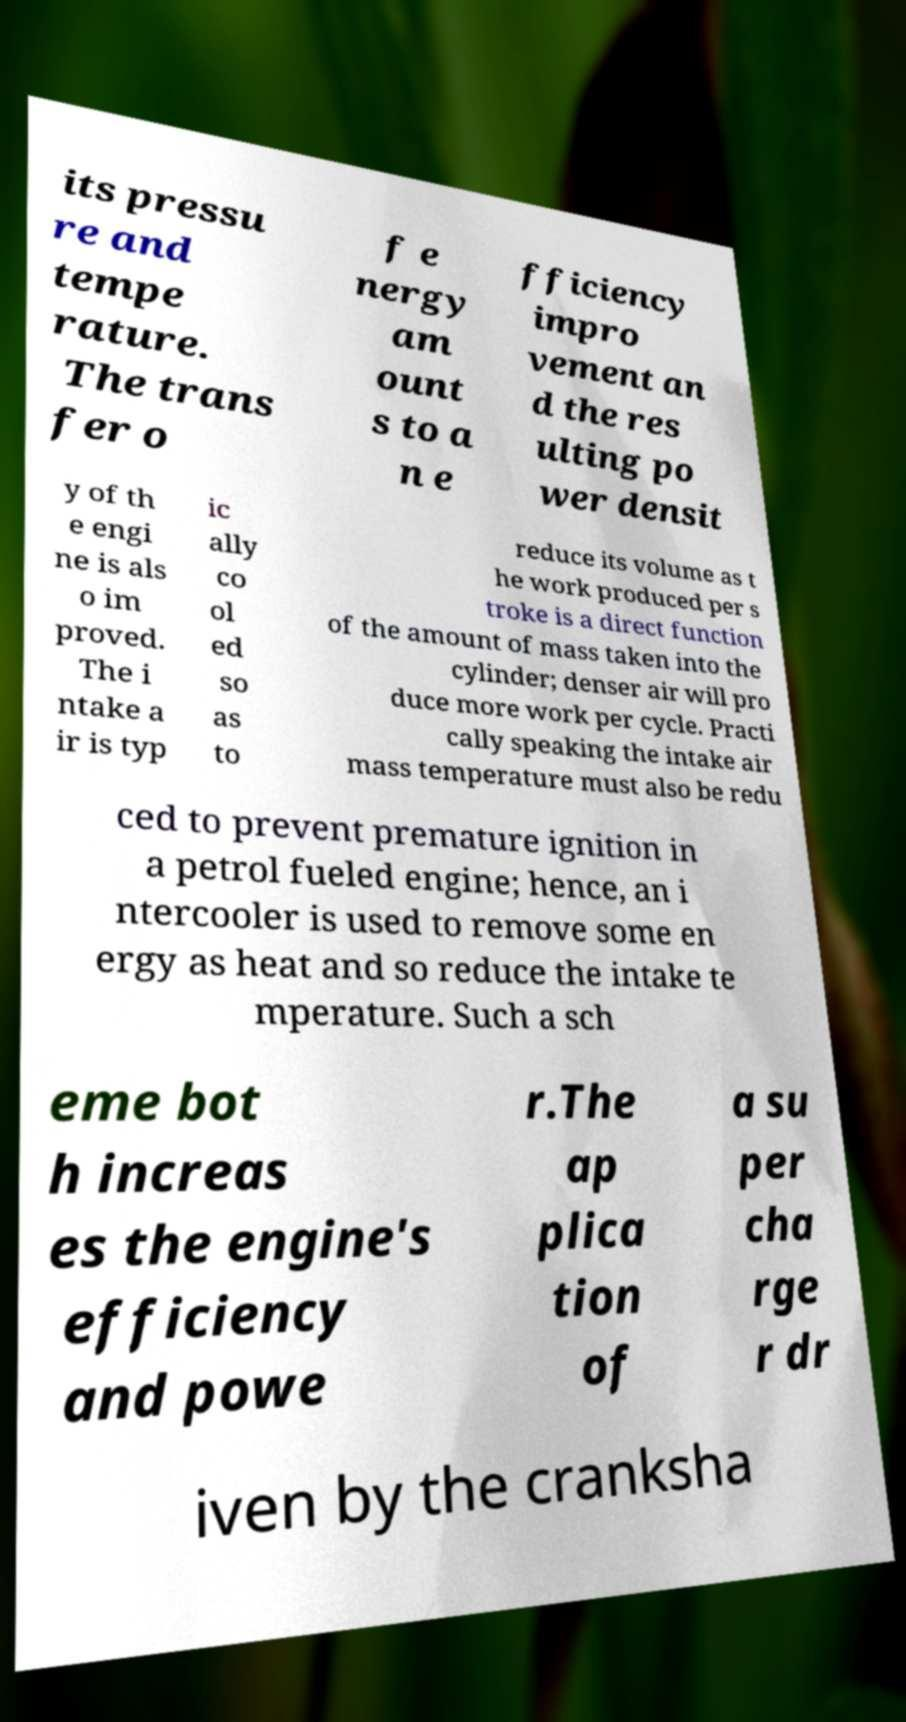For documentation purposes, I need the text within this image transcribed. Could you provide that? its pressu re and tempe rature. The trans fer o f e nergy am ount s to a n e fficiency impro vement an d the res ulting po wer densit y of th e engi ne is als o im proved. The i ntake a ir is typ ic ally co ol ed so as to reduce its volume as t he work produced per s troke is a direct function of the amount of mass taken into the cylinder; denser air will pro duce more work per cycle. Practi cally speaking the intake air mass temperature must also be redu ced to prevent premature ignition in a petrol fueled engine; hence, an i ntercooler is used to remove some en ergy as heat and so reduce the intake te mperature. Such a sch eme bot h increas es the engine's efficiency and powe r.The ap plica tion of a su per cha rge r dr iven by the cranksha 